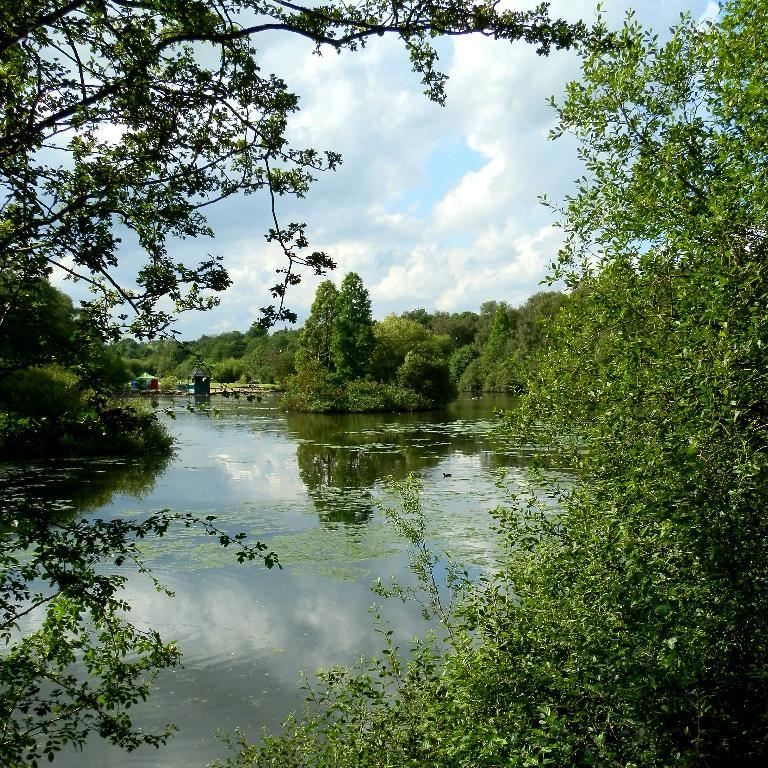What is the main feature of the image? There is a lake in the image. What can be seen around the lake? The lake is surrounded by trees. What type of shoes can be seen floating on the lake in the image? There are no shoes visible in the image; it only features a lake surrounded by trees. 